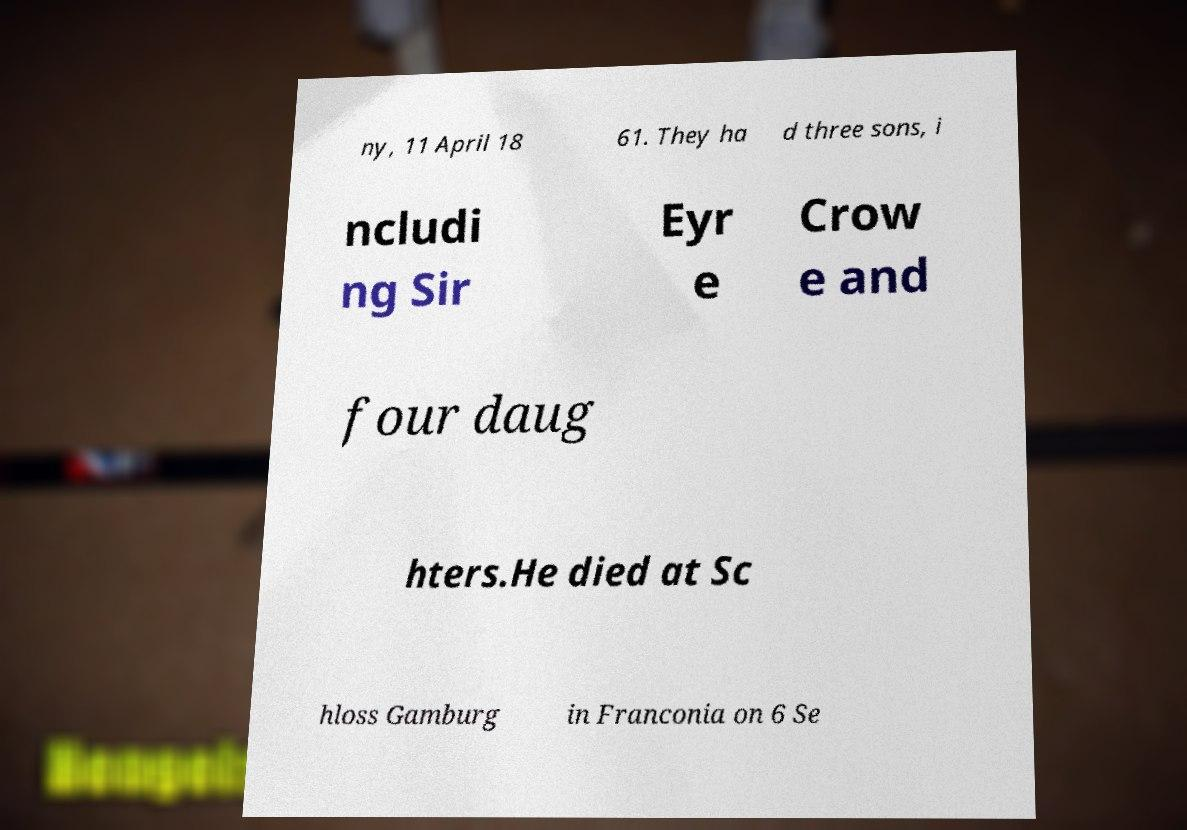Can you accurately transcribe the text from the provided image for me? ny, 11 April 18 61. They ha d three sons, i ncludi ng Sir Eyr e Crow e and four daug hters.He died at Sc hloss Gamburg in Franconia on 6 Se 